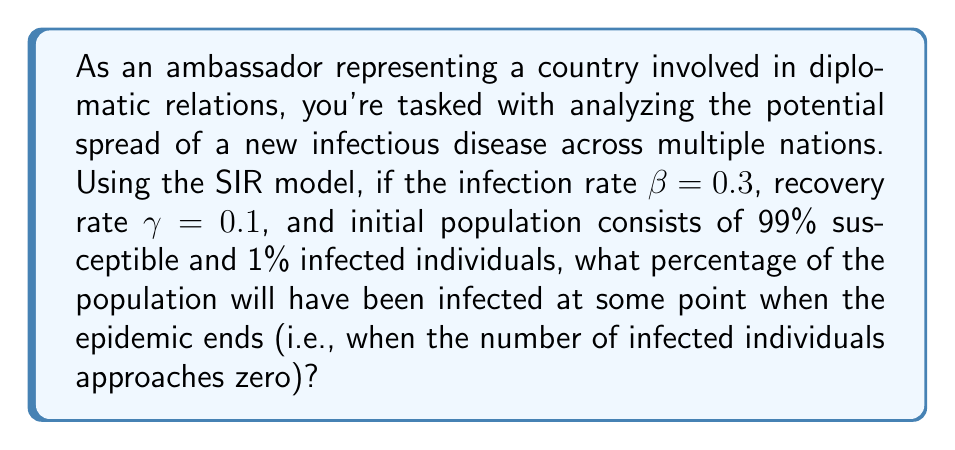Teach me how to tackle this problem. To solve this problem, we'll use the SIR (Susceptible-Infected-Recovered) model and the concept of the basic reproduction number $R_0$.

1. Calculate $R_0$:
   $R_0 = \frac{\beta}{\gamma} = \frac{0.3}{0.1} = 3$

2. In the SIR model, the final size of the epidemic is related to $R_0$ through the equation:
   $$\ln(s_\infty) = R_0(s_\infty - 1)$$
   where $s_\infty$ is the fraction of the population that remains susceptible when the epidemic ends.

3. We need to solve this equation numerically. Let's use the Newton-Raphson method:
   $$x_{n+1} = x_n - \frac{f(x_n)}{f'(x_n)}$$
   where $f(x) = \ln(x) - R_0(x - 1)$ and $f'(x) = \frac{1}{x} - R_0$

4. Starting with $x_0 = 0.5$, we iterate:
   $x_1 \approx 0.0611$
   $x_2 \approx 0.0580$
   $x_3 \approx 0.0580$ (converged)

5. Therefore, $s_\infty \approx 0.0580$, meaning 5.80% of the population remains susceptible.

6. The percentage that has been infected at some point is:
   $100\% - 5.80\% = 94.20\%$

This result shows that a large proportion of the population will have been infected by the time the epidemic ends, highlighting the importance of early intervention and international cooperation in disease control.
Answer: Approximately 94.20% of the population will have been infected at some point when the epidemic ends. 